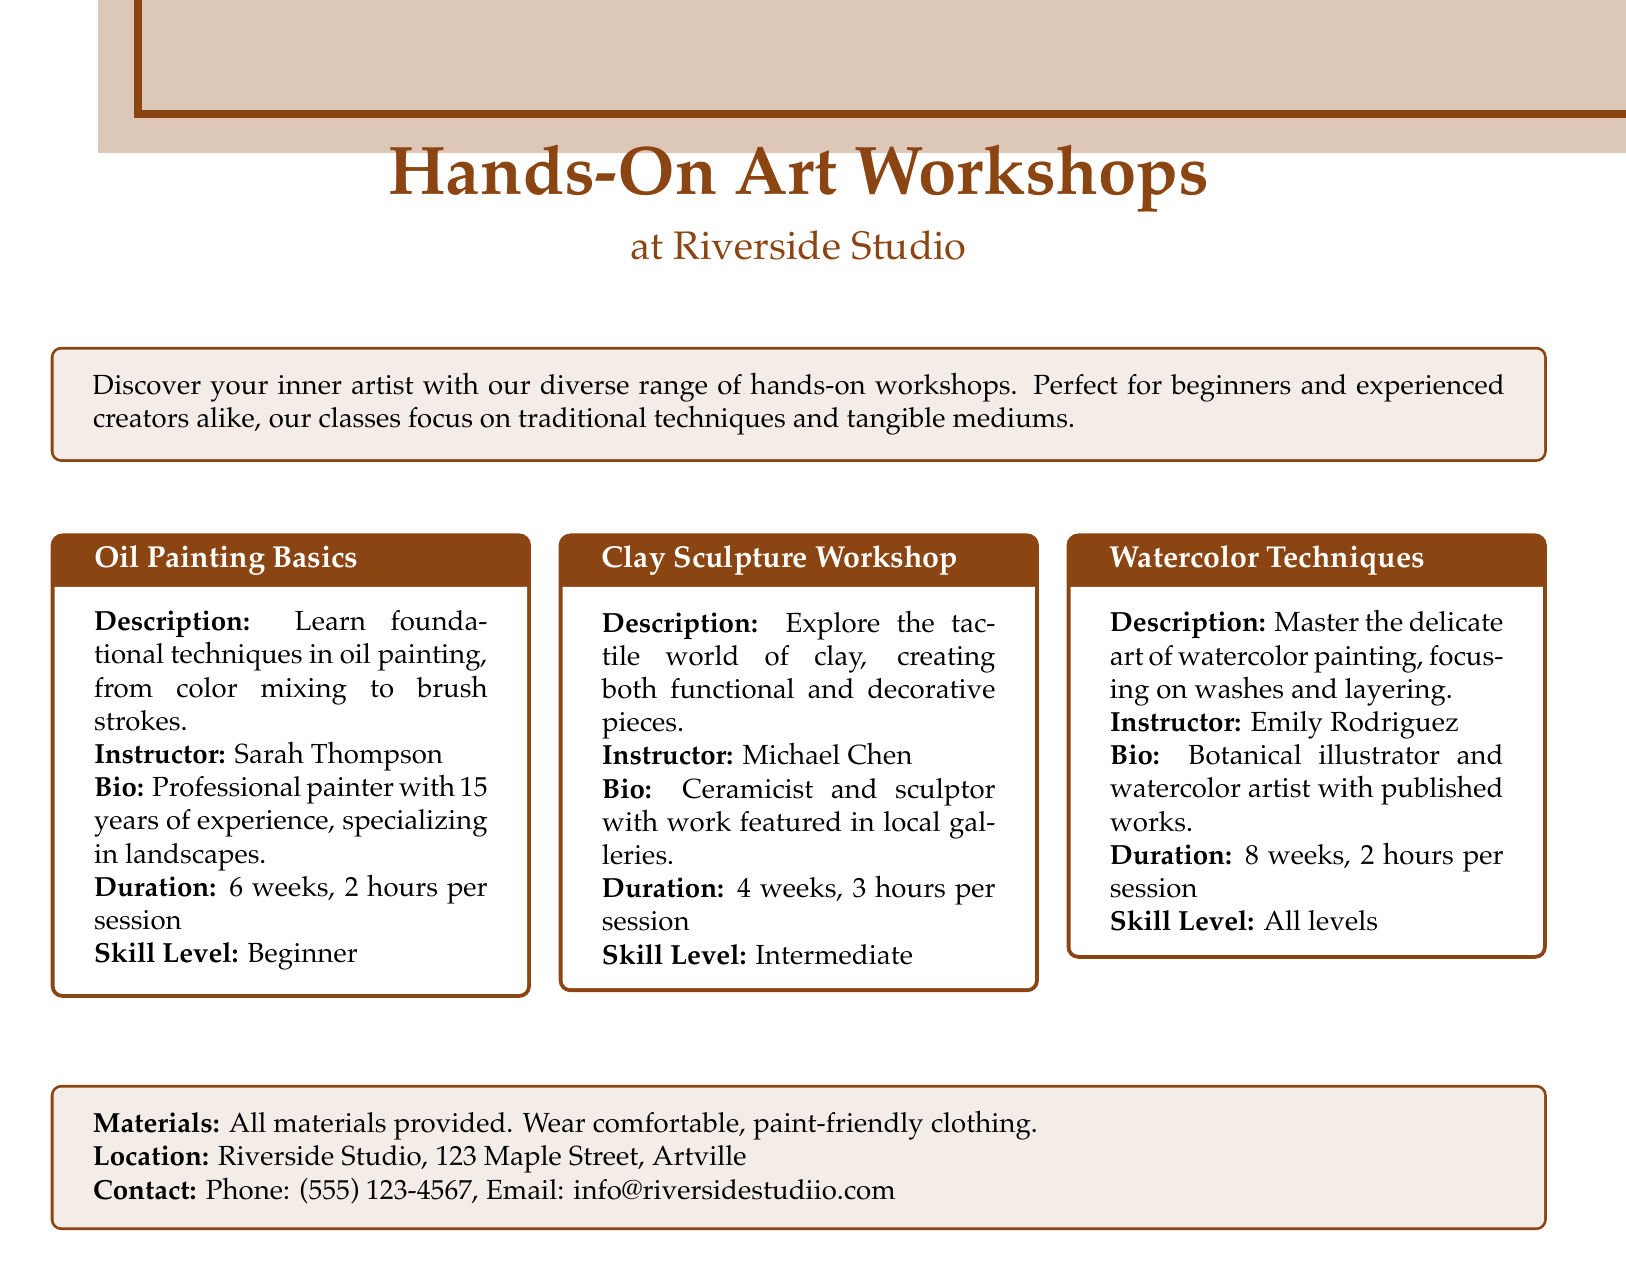what is the title of the first workshop? The title is specified within the tcolorbox for the first workshop listed.
Answer: Oil Painting Basics who is the instructor for the Clay Sculpture Workshop? The instructor's name is provided in the description section of the Clay Sculpture Workshop.
Answer: Michael Chen how long does the Watercolor Techniques class last? The duration is mentioned in the workshop details, specifically how many weeks it runs and the hours per session.
Answer: 8 weeks what is the skill level for Oil Painting Basics? The skill level is indicated in the workshop description for Oil Painting Basics.
Answer: Beginner how many hours is each session of the Clay Sculpture Workshop? The number of hours per session is specified in the workshop details.
Answer: 3 hours which instructor specializes in botanical illustration? The specialized field of the instructor is mentioned in the bio section related to the Watercolor Techniques workshop.
Answer: Emily Rodriguez how many workshops are listed in the document? The document lists a total of three workshops in separate tcolorboxes.
Answer: 3 what materials are provided in the workshops? The material provision is summarized in a section at the bottom of the document.
Answer: All materials provided what is the address of the Riverside Studio? The address is given in the contact information section of the document.
Answer: 123 Maple Street, Artville 